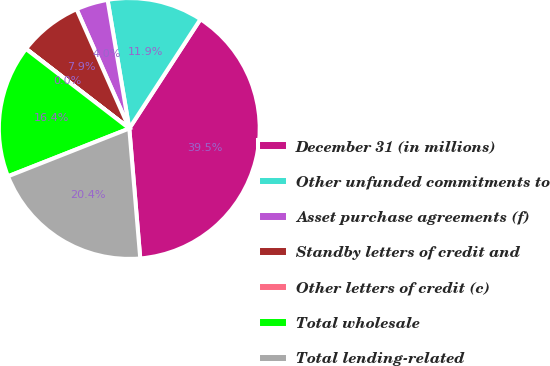<chart> <loc_0><loc_0><loc_500><loc_500><pie_chart><fcel>December 31 (in millions)<fcel>Other unfunded commitments to<fcel>Asset purchase agreements (f)<fcel>Standby letters of credit and<fcel>Other letters of credit (c)<fcel>Total wholesale<fcel>Total lending-related<nl><fcel>39.47%<fcel>11.85%<fcel>3.96%<fcel>7.91%<fcel>0.02%<fcel>16.42%<fcel>20.36%<nl></chart> 